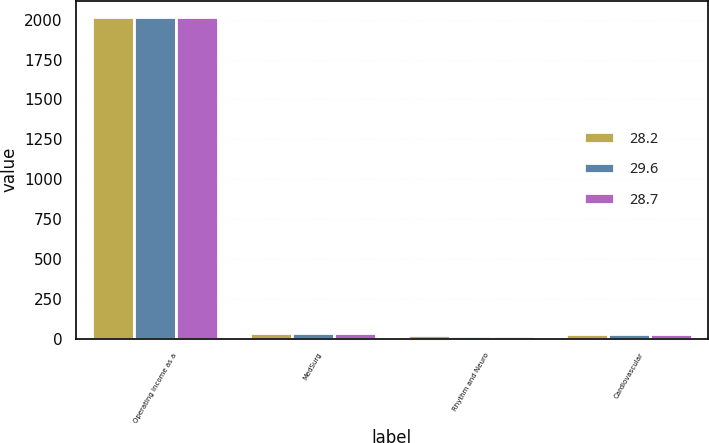Convert chart. <chart><loc_0><loc_0><loc_500><loc_500><stacked_bar_chart><ecel><fcel>Operating income as a<fcel>MedSurg<fcel>Rhythm and Neuro<fcel>Cardiovascular<nl><fcel>28.2<fcel>2018<fcel>36.7<fcel>21.5<fcel>29.6<nl><fcel>29.6<fcel>2017<fcel>35.9<fcel>19.1<fcel>28.2<nl><fcel>28.7<fcel>2016<fcel>34.9<fcel>15.2<fcel>28.7<nl></chart> 